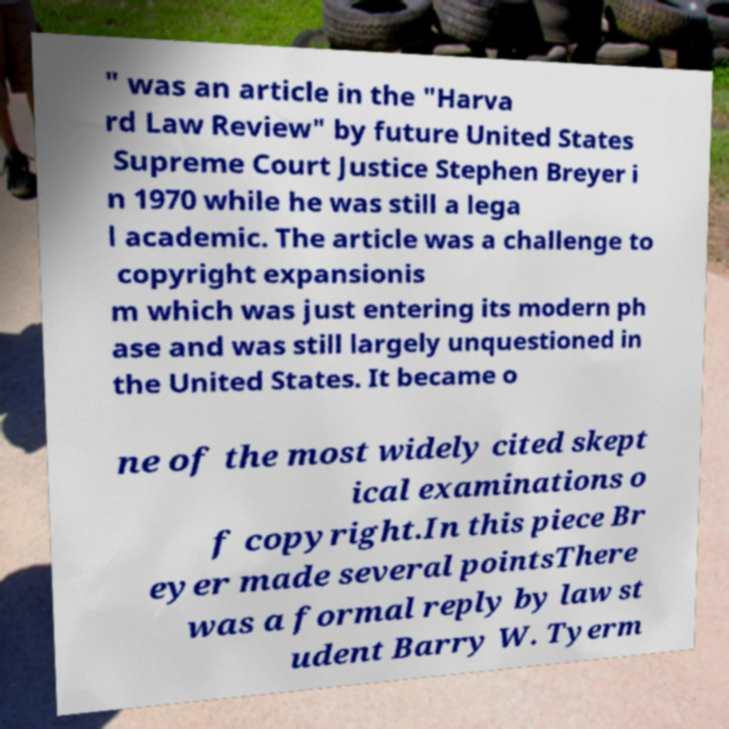What messages or text are displayed in this image? I need them in a readable, typed format. " was an article in the "Harva rd Law Review" by future United States Supreme Court Justice Stephen Breyer i n 1970 while he was still a lega l academic. The article was a challenge to copyright expansionis m which was just entering its modern ph ase and was still largely unquestioned in the United States. It became o ne of the most widely cited skept ical examinations o f copyright.In this piece Br eyer made several pointsThere was a formal reply by law st udent Barry W. Tyerm 